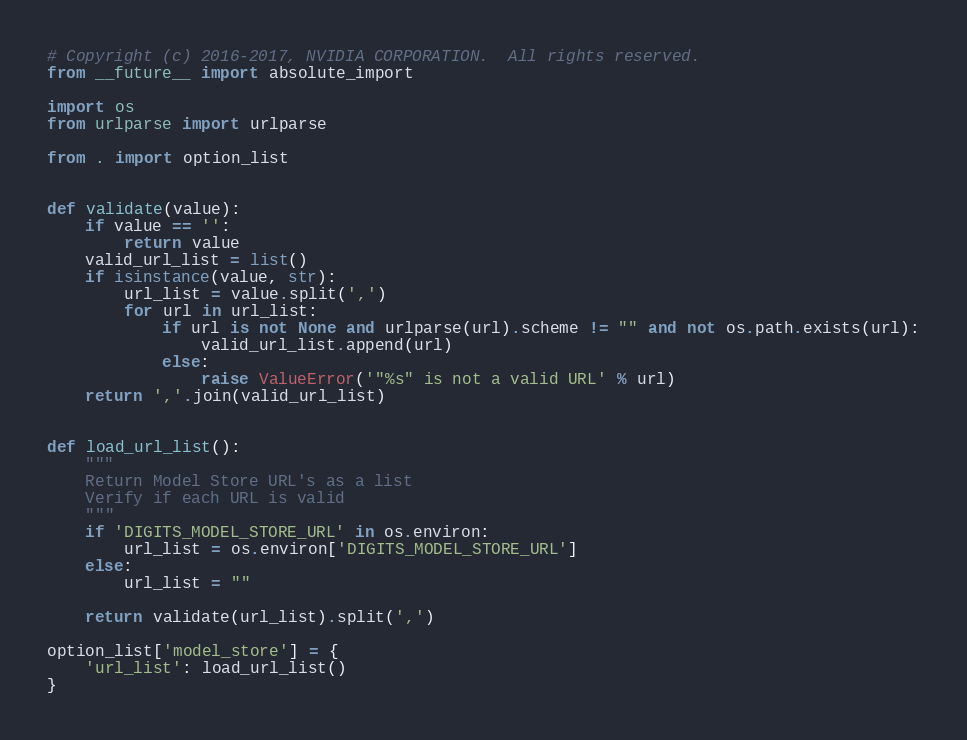Convert code to text. <code><loc_0><loc_0><loc_500><loc_500><_Python_># Copyright (c) 2016-2017, NVIDIA CORPORATION.  All rights reserved.
from __future__ import absolute_import

import os
from urlparse import urlparse

from . import option_list


def validate(value):
    if value == '':
        return value
    valid_url_list = list()
    if isinstance(value, str):
        url_list = value.split(',')
        for url in url_list:
            if url is not None and urlparse(url).scheme != "" and not os.path.exists(url):
                valid_url_list.append(url)
            else:
                raise ValueError('"%s" is not a valid URL' % url)
    return ','.join(valid_url_list)


def load_url_list():
    """
    Return Model Store URL's as a list
    Verify if each URL is valid
    """
    if 'DIGITS_MODEL_STORE_URL' in os.environ:
        url_list = os.environ['DIGITS_MODEL_STORE_URL']
    else:
        url_list = ""

    return validate(url_list).split(',')

option_list['model_store'] = {
    'url_list': load_url_list()
}
</code> 